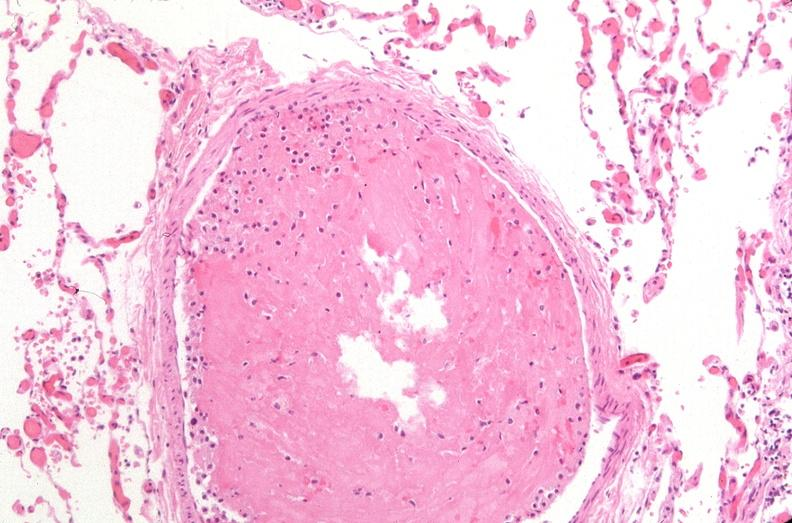what is present?
Answer the question using a single word or phrase. Respiratory 